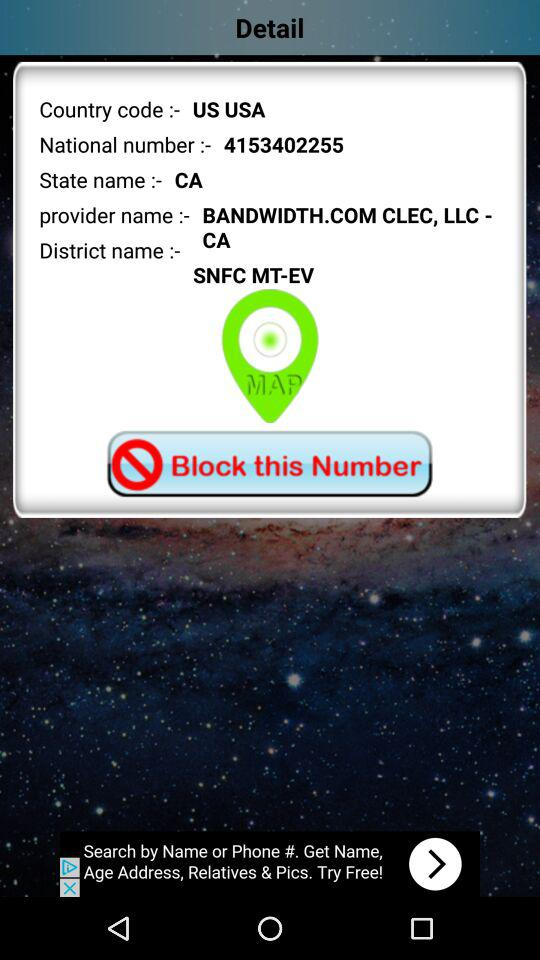What is the national number? The national number is 4153402255. 